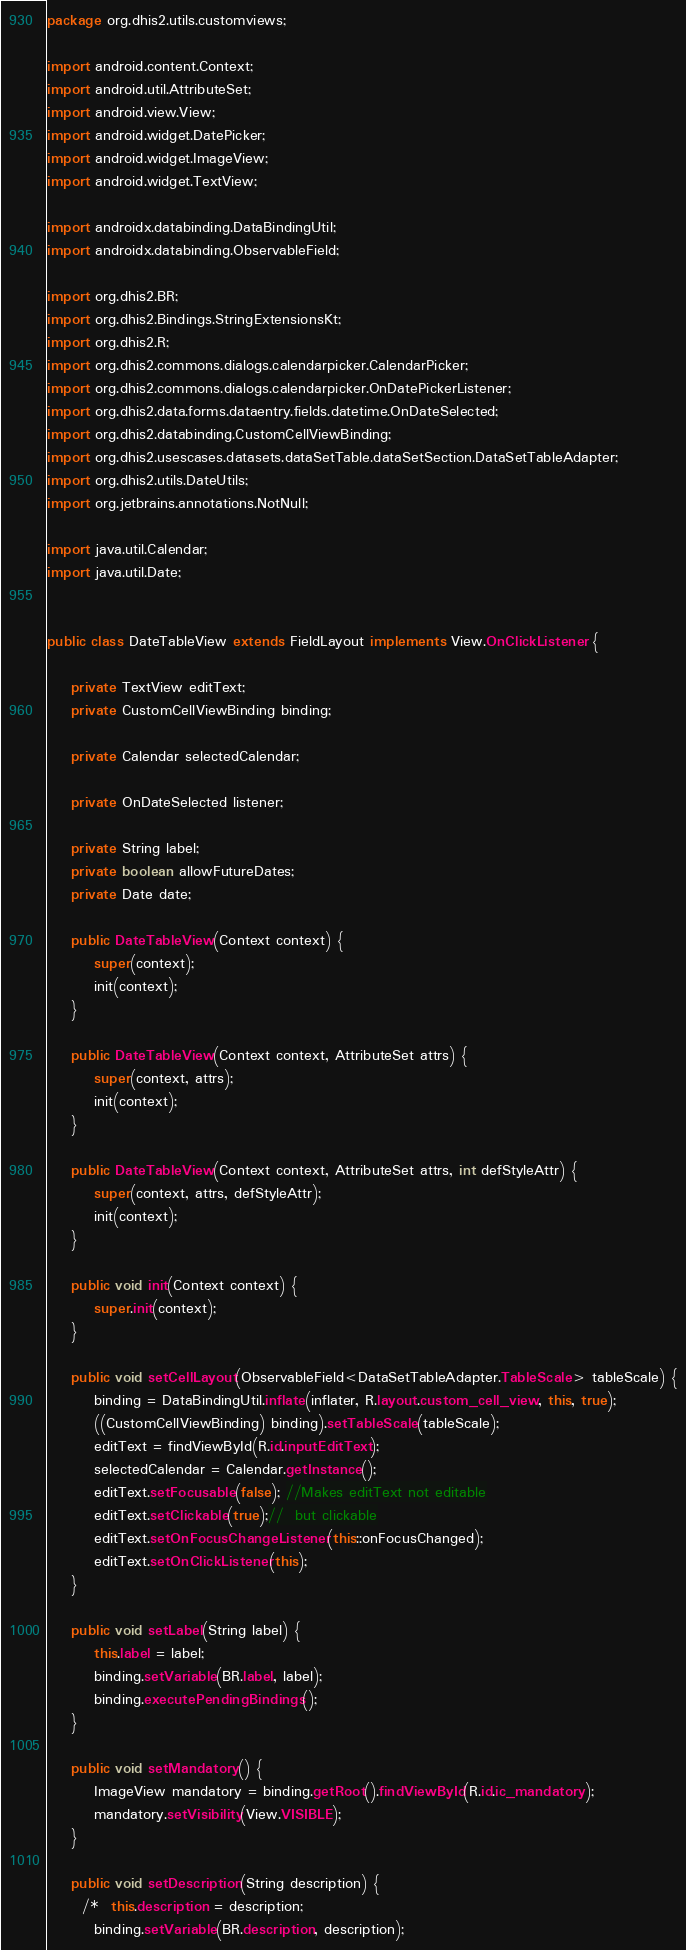<code> <loc_0><loc_0><loc_500><loc_500><_Java_>package org.dhis2.utils.customviews;

import android.content.Context;
import android.util.AttributeSet;
import android.view.View;
import android.widget.DatePicker;
import android.widget.ImageView;
import android.widget.TextView;

import androidx.databinding.DataBindingUtil;
import androidx.databinding.ObservableField;

import org.dhis2.BR;
import org.dhis2.Bindings.StringExtensionsKt;
import org.dhis2.R;
import org.dhis2.commons.dialogs.calendarpicker.CalendarPicker;
import org.dhis2.commons.dialogs.calendarpicker.OnDatePickerListener;
import org.dhis2.data.forms.dataentry.fields.datetime.OnDateSelected;
import org.dhis2.databinding.CustomCellViewBinding;
import org.dhis2.usescases.datasets.dataSetTable.dataSetSection.DataSetTableAdapter;
import org.dhis2.utils.DateUtils;
import org.jetbrains.annotations.NotNull;

import java.util.Calendar;
import java.util.Date;


public class DateTableView extends FieldLayout implements View.OnClickListener {

    private TextView editText;
    private CustomCellViewBinding binding;

    private Calendar selectedCalendar;

    private OnDateSelected listener;

    private String label;
    private boolean allowFutureDates;
    private Date date;

    public DateTableView(Context context) {
        super(context);
        init(context);
    }

    public DateTableView(Context context, AttributeSet attrs) {
        super(context, attrs);
        init(context);
    }

    public DateTableView(Context context, AttributeSet attrs, int defStyleAttr) {
        super(context, attrs, defStyleAttr);
        init(context);
    }

    public void init(Context context) {
        super.init(context);
    }

    public void setCellLayout(ObservableField<DataSetTableAdapter.TableScale> tableScale) {
        binding = DataBindingUtil.inflate(inflater, R.layout.custom_cell_view, this, true);
        ((CustomCellViewBinding) binding).setTableScale(tableScale);
        editText = findViewById(R.id.inputEditText);
        selectedCalendar = Calendar.getInstance();
        editText.setFocusable(false); //Makes editText not editable
        editText.setClickable(true);//  but clickable
        editText.setOnFocusChangeListener(this::onFocusChanged);
        editText.setOnClickListener(this);
    }

    public void setLabel(String label) {
        this.label = label;
        binding.setVariable(BR.label, label);
        binding.executePendingBindings();
    }

    public void setMandatory() {
        ImageView mandatory = binding.getRoot().findViewById(R.id.ic_mandatory);
        mandatory.setVisibility(View.VISIBLE);
    }

    public void setDescription(String description) {
      /*  this.description = description;
        binding.setVariable(BR.description, description);</code> 